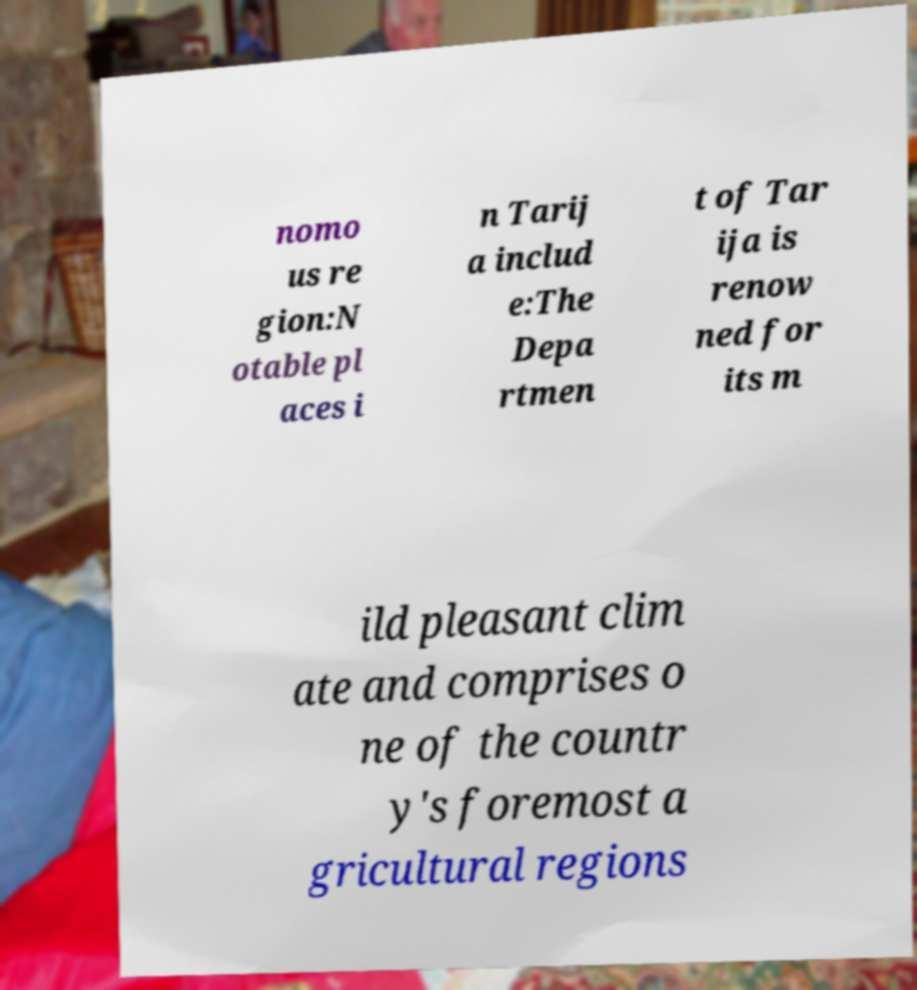Can you accurately transcribe the text from the provided image for me? nomo us re gion:N otable pl aces i n Tarij a includ e:The Depa rtmen t of Tar ija is renow ned for its m ild pleasant clim ate and comprises o ne of the countr y's foremost a gricultural regions 